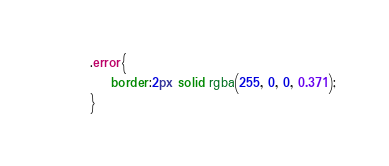Convert code to text. <code><loc_0><loc_0><loc_500><loc_500><_CSS_>.error{
    border:2px solid rgba(255, 0, 0, 0.371);
}</code> 